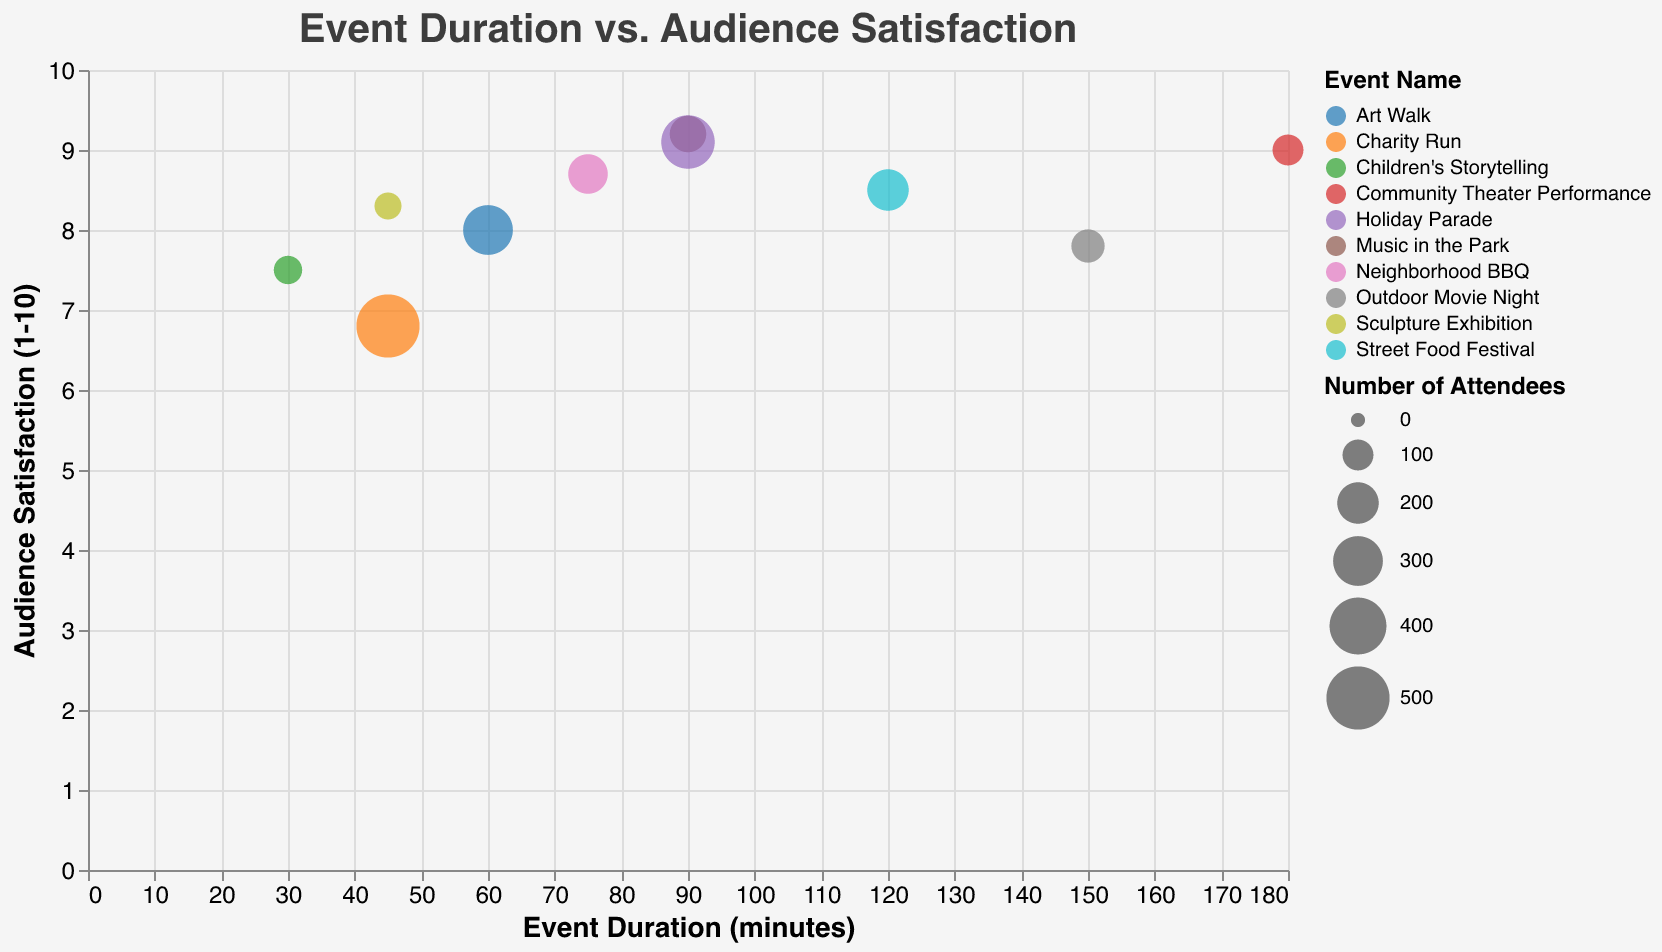What's the title of the plot? The title is displayed at the top of the plot. The title text is "Event Duration vs. Audience Satisfaction".
Answer: Event Duration vs. Audience Satisfaction How many total events are displayed in the plot? Count the number of unique event names in the tooltip data or the legend. There are 10 unique events listed.
Answer: 10 Which event had the highest audience satisfaction? Look at the y-axis for the highest point and check its corresponding event name via color legend or tooltip. "Music in the Park" has an audience satisfaction of 9.2, the highest.
Answer: Music in the Park What is the color used to represent "Charity Run"? Refer to the legend that maps colors to event names. The specific color for "Charity Run" can be seen here.
Answer: (Provide the actual color, e.g., "blue" or a similar descriptor if known) Which event has the largest number of attendees? The size of bubbles represents the number of attendees. Identify the largest bubble and use the tooltip to find it. The "Charity Run" has the most attendees with 500 people.
Answer: Charity Run What is the average duration of events with an audience satisfaction rating over 8.5? Filter out events with a satisfaction rating above 8.5 and find their durations: "Music in the Park" (90 min), "Community Theater Performance" (180 min), "Holiday Parade" (90 min), "Neighborhood BBQ" (75 min). Add these (90+180+90+75=435) and divide by the number of events (4). 435/4 = 108.75 minutes.
Answer: 108.75 minutes Which event had the longest duration and what was its audience satisfaction rating? Look for the bubble at the far right of the x-axis. The "Community Theater Performance" has the longest duration of 180 minutes with an audience satisfaction of 9.0.
Answer: Community Theater Performance with 9.0 satisfaction Is there any instance where a shorter event has a higher satisfaction rating than a longer event? Provide an example. Compare points visually where shorter duration events have higher audience satisfaction. For example, "Music in the Park" (90 min, 9.2 rating) has a higher satisfaction rating than "Outdoor Movie Night" (150 min, 7.8 rating).
Answer: Music in the Park vs. Outdoor Movie Night Which event, lasting under 60 minutes, has the highest audience satisfaction, and what is it? Identify bubbles with durations less than 60 minutes and compare their satisfaction ratings. "Sculpture Exhibition" at 45 minutes has the highest satisfaction rating of 8.3.
Answer: Sculpture Exhibition with 8.3 Does the plot suggest that longer events generally have higher audience satisfaction? Compare satisfaction ratings across different event durations visually and through the tooltip. Events of various durations (short and long) span high and low satisfaction ratings, indicating no clear trend.
Answer: No clear trend 